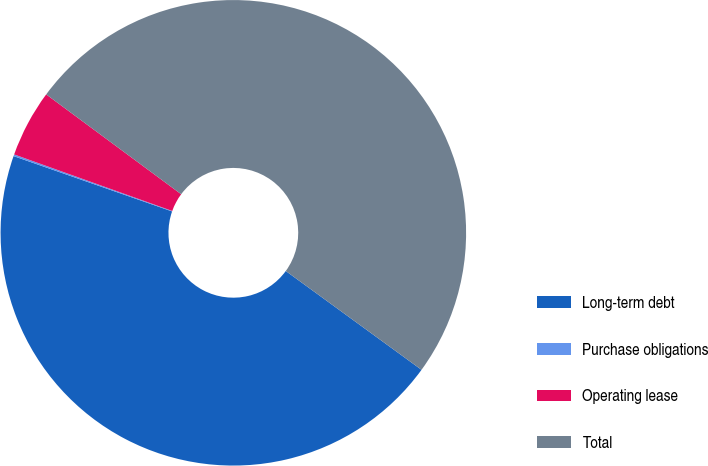<chart> <loc_0><loc_0><loc_500><loc_500><pie_chart><fcel>Long-term debt<fcel>Purchase obligations<fcel>Operating lease<fcel>Total<nl><fcel>45.33%<fcel>0.12%<fcel>4.67%<fcel>49.88%<nl></chart> 